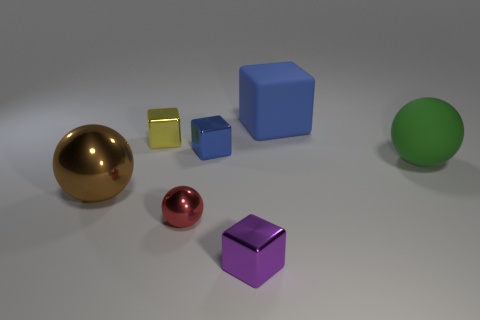How many blue blocks must be subtracted to get 1 blue blocks? 1 Subtract 2 blue blocks. How many objects are left? 5 Subtract all cubes. How many objects are left? 3 Subtract 1 cubes. How many cubes are left? 3 Subtract all cyan cubes. Subtract all gray spheres. How many cubes are left? 4 Subtract all gray spheres. How many brown blocks are left? 0 Subtract all cubes. Subtract all large brown rubber blocks. How many objects are left? 3 Add 5 big brown shiny objects. How many big brown shiny objects are left? 6 Add 7 tiny yellow shiny cubes. How many tiny yellow shiny cubes exist? 8 Add 3 metal spheres. How many objects exist? 10 